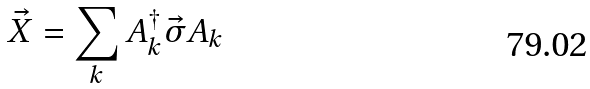Convert formula to latex. <formula><loc_0><loc_0><loc_500><loc_500>\vec { X } = \sum _ { k } A ^ { \dag } _ { k } \vec { \sigma } A _ { k }</formula> 